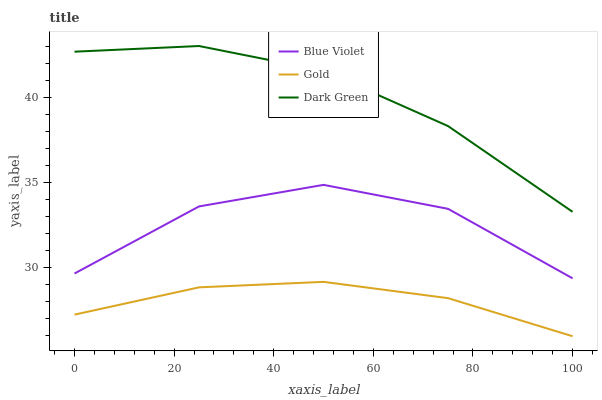Does Gold have the minimum area under the curve?
Answer yes or no. Yes. Does Dark Green have the maximum area under the curve?
Answer yes or no. Yes. Does Blue Violet have the minimum area under the curve?
Answer yes or no. No. Does Blue Violet have the maximum area under the curve?
Answer yes or no. No. Is Gold the smoothest?
Answer yes or no. Yes. Is Blue Violet the roughest?
Answer yes or no. Yes. Is Dark Green the smoothest?
Answer yes or no. No. Is Dark Green the roughest?
Answer yes or no. No. Does Blue Violet have the lowest value?
Answer yes or no. No. Does Blue Violet have the highest value?
Answer yes or no. No. Is Gold less than Dark Green?
Answer yes or no. Yes. Is Blue Violet greater than Gold?
Answer yes or no. Yes. Does Gold intersect Dark Green?
Answer yes or no. No. 